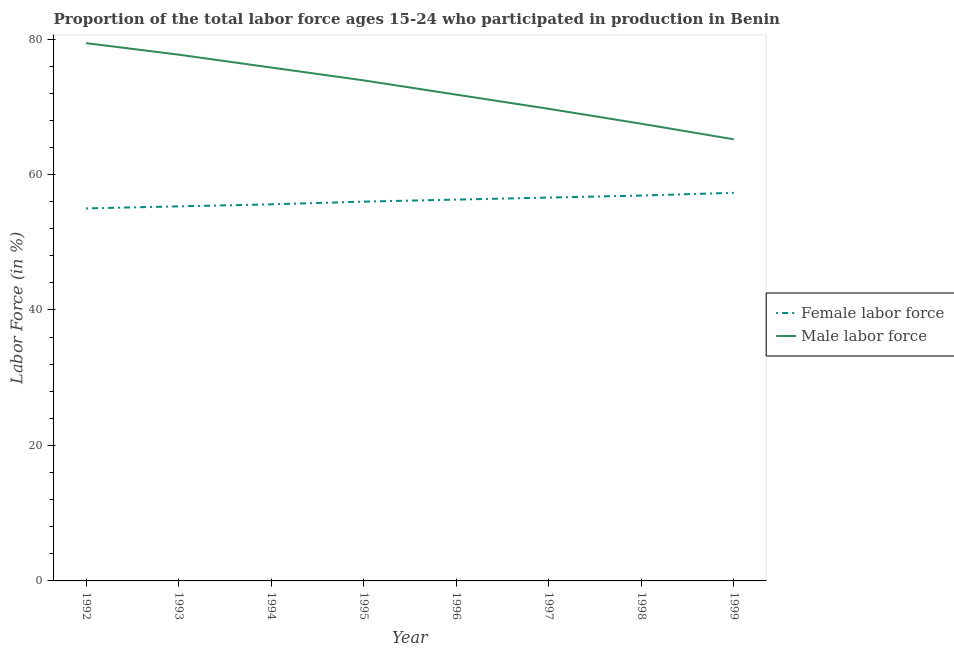How many different coloured lines are there?
Ensure brevity in your answer.  2. Does the line corresponding to percentage of male labour force intersect with the line corresponding to percentage of female labor force?
Give a very brief answer. No. Is the number of lines equal to the number of legend labels?
Your response must be concise. Yes. Across all years, what is the maximum percentage of female labor force?
Provide a short and direct response. 57.3. In which year was the percentage of female labor force maximum?
Your response must be concise. 1999. What is the total percentage of female labor force in the graph?
Provide a succinct answer. 449. What is the difference between the percentage of male labour force in 1992 and that in 1994?
Keep it short and to the point. 3.6. What is the difference between the percentage of male labour force in 1999 and the percentage of female labor force in 1992?
Make the answer very short. 10.2. What is the average percentage of female labor force per year?
Ensure brevity in your answer.  56.12. In the year 1992, what is the difference between the percentage of female labor force and percentage of male labour force?
Provide a short and direct response. -24.4. What is the ratio of the percentage of female labor force in 1993 to that in 1994?
Offer a very short reply. 0.99. Is the percentage of male labour force in 1994 less than that in 1995?
Provide a succinct answer. No. What is the difference between the highest and the second highest percentage of male labour force?
Ensure brevity in your answer.  1.7. What is the difference between the highest and the lowest percentage of female labor force?
Your response must be concise. 2.3. In how many years, is the percentage of male labour force greater than the average percentage of male labour force taken over all years?
Your response must be concise. 4. Is the sum of the percentage of male labour force in 1996 and 1997 greater than the maximum percentage of female labor force across all years?
Keep it short and to the point. Yes. Is the percentage of male labour force strictly less than the percentage of female labor force over the years?
Your answer should be compact. No. How many lines are there?
Your response must be concise. 2. Does the graph contain any zero values?
Make the answer very short. No. Does the graph contain grids?
Give a very brief answer. No. What is the title of the graph?
Give a very brief answer. Proportion of the total labor force ages 15-24 who participated in production in Benin. What is the Labor Force (in %) in Male labor force in 1992?
Make the answer very short. 79.4. What is the Labor Force (in %) of Female labor force in 1993?
Ensure brevity in your answer.  55.3. What is the Labor Force (in %) of Male labor force in 1993?
Offer a terse response. 77.7. What is the Labor Force (in %) of Female labor force in 1994?
Offer a terse response. 55.6. What is the Labor Force (in %) in Male labor force in 1994?
Your answer should be compact. 75.8. What is the Labor Force (in %) in Female labor force in 1995?
Ensure brevity in your answer.  56. What is the Labor Force (in %) in Male labor force in 1995?
Provide a short and direct response. 73.9. What is the Labor Force (in %) in Female labor force in 1996?
Give a very brief answer. 56.3. What is the Labor Force (in %) in Male labor force in 1996?
Your response must be concise. 71.8. What is the Labor Force (in %) of Female labor force in 1997?
Your response must be concise. 56.6. What is the Labor Force (in %) in Male labor force in 1997?
Your answer should be compact. 69.7. What is the Labor Force (in %) of Female labor force in 1998?
Give a very brief answer. 56.9. What is the Labor Force (in %) of Male labor force in 1998?
Your response must be concise. 67.5. What is the Labor Force (in %) in Female labor force in 1999?
Offer a terse response. 57.3. What is the Labor Force (in %) in Male labor force in 1999?
Your response must be concise. 65.2. Across all years, what is the maximum Labor Force (in %) of Female labor force?
Your answer should be compact. 57.3. Across all years, what is the maximum Labor Force (in %) of Male labor force?
Offer a very short reply. 79.4. Across all years, what is the minimum Labor Force (in %) of Male labor force?
Offer a terse response. 65.2. What is the total Labor Force (in %) in Female labor force in the graph?
Provide a short and direct response. 449. What is the total Labor Force (in %) in Male labor force in the graph?
Make the answer very short. 581. What is the difference between the Labor Force (in %) in Female labor force in 1992 and that in 1993?
Give a very brief answer. -0.3. What is the difference between the Labor Force (in %) of Male labor force in 1992 and that in 1993?
Keep it short and to the point. 1.7. What is the difference between the Labor Force (in %) in Female labor force in 1992 and that in 1994?
Offer a terse response. -0.6. What is the difference between the Labor Force (in %) in Male labor force in 1992 and that in 1996?
Make the answer very short. 7.6. What is the difference between the Labor Force (in %) of Male labor force in 1992 and that in 1999?
Keep it short and to the point. 14.2. What is the difference between the Labor Force (in %) in Female labor force in 1993 and that in 1994?
Keep it short and to the point. -0.3. What is the difference between the Labor Force (in %) of Female labor force in 1993 and that in 1995?
Your answer should be very brief. -0.7. What is the difference between the Labor Force (in %) in Male labor force in 1993 and that in 1996?
Give a very brief answer. 5.9. What is the difference between the Labor Force (in %) of Female labor force in 1993 and that in 1998?
Provide a short and direct response. -1.6. What is the difference between the Labor Force (in %) in Female labor force in 1993 and that in 1999?
Your response must be concise. -2. What is the difference between the Labor Force (in %) in Male labor force in 1993 and that in 1999?
Provide a succinct answer. 12.5. What is the difference between the Labor Force (in %) of Male labor force in 1994 and that in 1995?
Provide a succinct answer. 1.9. What is the difference between the Labor Force (in %) in Female labor force in 1994 and that in 1996?
Make the answer very short. -0.7. What is the difference between the Labor Force (in %) of Male labor force in 1994 and that in 1996?
Ensure brevity in your answer.  4. What is the difference between the Labor Force (in %) of Female labor force in 1994 and that in 1998?
Give a very brief answer. -1.3. What is the difference between the Labor Force (in %) of Male labor force in 1994 and that in 1999?
Your answer should be compact. 10.6. What is the difference between the Labor Force (in %) in Male labor force in 1995 and that in 1997?
Keep it short and to the point. 4.2. What is the difference between the Labor Force (in %) in Female labor force in 1995 and that in 1998?
Make the answer very short. -0.9. What is the difference between the Labor Force (in %) in Male labor force in 1995 and that in 1999?
Give a very brief answer. 8.7. What is the difference between the Labor Force (in %) of Male labor force in 1996 and that in 1997?
Make the answer very short. 2.1. What is the difference between the Labor Force (in %) in Female labor force in 1996 and that in 1998?
Provide a short and direct response. -0.6. What is the difference between the Labor Force (in %) in Male labor force in 1996 and that in 1998?
Keep it short and to the point. 4.3. What is the difference between the Labor Force (in %) in Male labor force in 1997 and that in 1998?
Your response must be concise. 2.2. What is the difference between the Labor Force (in %) in Female labor force in 1997 and that in 1999?
Make the answer very short. -0.7. What is the difference between the Labor Force (in %) of Male labor force in 1997 and that in 1999?
Give a very brief answer. 4.5. What is the difference between the Labor Force (in %) of Female labor force in 1998 and that in 1999?
Ensure brevity in your answer.  -0.4. What is the difference between the Labor Force (in %) in Male labor force in 1998 and that in 1999?
Ensure brevity in your answer.  2.3. What is the difference between the Labor Force (in %) in Female labor force in 1992 and the Labor Force (in %) in Male labor force in 1993?
Provide a short and direct response. -22.7. What is the difference between the Labor Force (in %) of Female labor force in 1992 and the Labor Force (in %) of Male labor force in 1994?
Offer a terse response. -20.8. What is the difference between the Labor Force (in %) of Female labor force in 1992 and the Labor Force (in %) of Male labor force in 1995?
Provide a short and direct response. -18.9. What is the difference between the Labor Force (in %) of Female labor force in 1992 and the Labor Force (in %) of Male labor force in 1996?
Offer a terse response. -16.8. What is the difference between the Labor Force (in %) in Female labor force in 1992 and the Labor Force (in %) in Male labor force in 1997?
Keep it short and to the point. -14.7. What is the difference between the Labor Force (in %) of Female labor force in 1992 and the Labor Force (in %) of Male labor force in 1998?
Give a very brief answer. -12.5. What is the difference between the Labor Force (in %) of Female labor force in 1992 and the Labor Force (in %) of Male labor force in 1999?
Ensure brevity in your answer.  -10.2. What is the difference between the Labor Force (in %) in Female labor force in 1993 and the Labor Force (in %) in Male labor force in 1994?
Keep it short and to the point. -20.5. What is the difference between the Labor Force (in %) of Female labor force in 1993 and the Labor Force (in %) of Male labor force in 1995?
Keep it short and to the point. -18.6. What is the difference between the Labor Force (in %) in Female labor force in 1993 and the Labor Force (in %) in Male labor force in 1996?
Your answer should be compact. -16.5. What is the difference between the Labor Force (in %) of Female labor force in 1993 and the Labor Force (in %) of Male labor force in 1997?
Provide a short and direct response. -14.4. What is the difference between the Labor Force (in %) in Female labor force in 1994 and the Labor Force (in %) in Male labor force in 1995?
Provide a short and direct response. -18.3. What is the difference between the Labor Force (in %) of Female labor force in 1994 and the Labor Force (in %) of Male labor force in 1996?
Offer a very short reply. -16.2. What is the difference between the Labor Force (in %) of Female labor force in 1994 and the Labor Force (in %) of Male labor force in 1997?
Provide a short and direct response. -14.1. What is the difference between the Labor Force (in %) of Female labor force in 1995 and the Labor Force (in %) of Male labor force in 1996?
Your answer should be very brief. -15.8. What is the difference between the Labor Force (in %) of Female labor force in 1995 and the Labor Force (in %) of Male labor force in 1997?
Offer a terse response. -13.7. What is the difference between the Labor Force (in %) of Female labor force in 1996 and the Labor Force (in %) of Male labor force in 1997?
Make the answer very short. -13.4. What is the difference between the Labor Force (in %) of Female labor force in 1996 and the Labor Force (in %) of Male labor force in 1998?
Your answer should be very brief. -11.2. What is the difference between the Labor Force (in %) of Female labor force in 1996 and the Labor Force (in %) of Male labor force in 1999?
Offer a very short reply. -8.9. What is the difference between the Labor Force (in %) of Female labor force in 1997 and the Labor Force (in %) of Male labor force in 1999?
Offer a terse response. -8.6. What is the difference between the Labor Force (in %) of Female labor force in 1998 and the Labor Force (in %) of Male labor force in 1999?
Ensure brevity in your answer.  -8.3. What is the average Labor Force (in %) in Female labor force per year?
Offer a terse response. 56.12. What is the average Labor Force (in %) in Male labor force per year?
Offer a terse response. 72.62. In the year 1992, what is the difference between the Labor Force (in %) in Female labor force and Labor Force (in %) in Male labor force?
Your answer should be compact. -24.4. In the year 1993, what is the difference between the Labor Force (in %) in Female labor force and Labor Force (in %) in Male labor force?
Give a very brief answer. -22.4. In the year 1994, what is the difference between the Labor Force (in %) in Female labor force and Labor Force (in %) in Male labor force?
Your answer should be compact. -20.2. In the year 1995, what is the difference between the Labor Force (in %) in Female labor force and Labor Force (in %) in Male labor force?
Your response must be concise. -17.9. In the year 1996, what is the difference between the Labor Force (in %) of Female labor force and Labor Force (in %) of Male labor force?
Offer a terse response. -15.5. In the year 1997, what is the difference between the Labor Force (in %) of Female labor force and Labor Force (in %) of Male labor force?
Your response must be concise. -13.1. In the year 1998, what is the difference between the Labor Force (in %) of Female labor force and Labor Force (in %) of Male labor force?
Ensure brevity in your answer.  -10.6. What is the ratio of the Labor Force (in %) of Female labor force in 1992 to that in 1993?
Your answer should be compact. 0.99. What is the ratio of the Labor Force (in %) in Male labor force in 1992 to that in 1993?
Make the answer very short. 1.02. What is the ratio of the Labor Force (in %) of Male labor force in 1992 to that in 1994?
Provide a succinct answer. 1.05. What is the ratio of the Labor Force (in %) of Female labor force in 1992 to that in 1995?
Make the answer very short. 0.98. What is the ratio of the Labor Force (in %) of Male labor force in 1992 to that in 1995?
Offer a terse response. 1.07. What is the ratio of the Labor Force (in %) in Female labor force in 1992 to that in 1996?
Offer a very short reply. 0.98. What is the ratio of the Labor Force (in %) of Male labor force in 1992 to that in 1996?
Provide a succinct answer. 1.11. What is the ratio of the Labor Force (in %) in Female labor force in 1992 to that in 1997?
Provide a succinct answer. 0.97. What is the ratio of the Labor Force (in %) of Male labor force in 1992 to that in 1997?
Keep it short and to the point. 1.14. What is the ratio of the Labor Force (in %) of Female labor force in 1992 to that in 1998?
Your answer should be compact. 0.97. What is the ratio of the Labor Force (in %) in Male labor force in 1992 to that in 1998?
Provide a short and direct response. 1.18. What is the ratio of the Labor Force (in %) of Female labor force in 1992 to that in 1999?
Ensure brevity in your answer.  0.96. What is the ratio of the Labor Force (in %) of Male labor force in 1992 to that in 1999?
Offer a very short reply. 1.22. What is the ratio of the Labor Force (in %) of Female labor force in 1993 to that in 1994?
Your response must be concise. 0.99. What is the ratio of the Labor Force (in %) of Male labor force in 1993 to that in 1994?
Provide a succinct answer. 1.03. What is the ratio of the Labor Force (in %) in Female labor force in 1993 to that in 1995?
Your answer should be very brief. 0.99. What is the ratio of the Labor Force (in %) in Male labor force in 1993 to that in 1995?
Your response must be concise. 1.05. What is the ratio of the Labor Force (in %) in Female labor force in 1993 to that in 1996?
Ensure brevity in your answer.  0.98. What is the ratio of the Labor Force (in %) of Male labor force in 1993 to that in 1996?
Ensure brevity in your answer.  1.08. What is the ratio of the Labor Force (in %) in Male labor force in 1993 to that in 1997?
Provide a succinct answer. 1.11. What is the ratio of the Labor Force (in %) in Female labor force in 1993 to that in 1998?
Make the answer very short. 0.97. What is the ratio of the Labor Force (in %) of Male labor force in 1993 to that in 1998?
Offer a very short reply. 1.15. What is the ratio of the Labor Force (in %) of Female labor force in 1993 to that in 1999?
Your answer should be compact. 0.97. What is the ratio of the Labor Force (in %) of Male labor force in 1993 to that in 1999?
Your response must be concise. 1.19. What is the ratio of the Labor Force (in %) in Male labor force in 1994 to that in 1995?
Give a very brief answer. 1.03. What is the ratio of the Labor Force (in %) of Female labor force in 1994 to that in 1996?
Give a very brief answer. 0.99. What is the ratio of the Labor Force (in %) of Male labor force in 1994 to that in 1996?
Provide a short and direct response. 1.06. What is the ratio of the Labor Force (in %) in Female labor force in 1994 to that in 1997?
Make the answer very short. 0.98. What is the ratio of the Labor Force (in %) in Male labor force in 1994 to that in 1997?
Keep it short and to the point. 1.09. What is the ratio of the Labor Force (in %) of Female labor force in 1994 to that in 1998?
Offer a very short reply. 0.98. What is the ratio of the Labor Force (in %) of Male labor force in 1994 to that in 1998?
Ensure brevity in your answer.  1.12. What is the ratio of the Labor Force (in %) in Female labor force in 1994 to that in 1999?
Provide a short and direct response. 0.97. What is the ratio of the Labor Force (in %) in Male labor force in 1994 to that in 1999?
Provide a succinct answer. 1.16. What is the ratio of the Labor Force (in %) of Female labor force in 1995 to that in 1996?
Your answer should be very brief. 0.99. What is the ratio of the Labor Force (in %) of Male labor force in 1995 to that in 1996?
Provide a short and direct response. 1.03. What is the ratio of the Labor Force (in %) in Male labor force in 1995 to that in 1997?
Provide a short and direct response. 1.06. What is the ratio of the Labor Force (in %) of Female labor force in 1995 to that in 1998?
Provide a succinct answer. 0.98. What is the ratio of the Labor Force (in %) in Male labor force in 1995 to that in 1998?
Ensure brevity in your answer.  1.09. What is the ratio of the Labor Force (in %) in Female labor force in 1995 to that in 1999?
Your answer should be very brief. 0.98. What is the ratio of the Labor Force (in %) of Male labor force in 1995 to that in 1999?
Make the answer very short. 1.13. What is the ratio of the Labor Force (in %) in Female labor force in 1996 to that in 1997?
Provide a short and direct response. 0.99. What is the ratio of the Labor Force (in %) in Male labor force in 1996 to that in 1997?
Make the answer very short. 1.03. What is the ratio of the Labor Force (in %) in Female labor force in 1996 to that in 1998?
Your answer should be compact. 0.99. What is the ratio of the Labor Force (in %) in Male labor force in 1996 to that in 1998?
Provide a short and direct response. 1.06. What is the ratio of the Labor Force (in %) in Female labor force in 1996 to that in 1999?
Provide a short and direct response. 0.98. What is the ratio of the Labor Force (in %) of Male labor force in 1996 to that in 1999?
Keep it short and to the point. 1.1. What is the ratio of the Labor Force (in %) in Female labor force in 1997 to that in 1998?
Give a very brief answer. 0.99. What is the ratio of the Labor Force (in %) in Male labor force in 1997 to that in 1998?
Offer a terse response. 1.03. What is the ratio of the Labor Force (in %) of Male labor force in 1997 to that in 1999?
Provide a short and direct response. 1.07. What is the ratio of the Labor Force (in %) of Male labor force in 1998 to that in 1999?
Make the answer very short. 1.04. What is the difference between the highest and the second highest Labor Force (in %) of Female labor force?
Your response must be concise. 0.4. What is the difference between the highest and the second highest Labor Force (in %) in Male labor force?
Your answer should be compact. 1.7. What is the difference between the highest and the lowest Labor Force (in %) of Male labor force?
Keep it short and to the point. 14.2. 